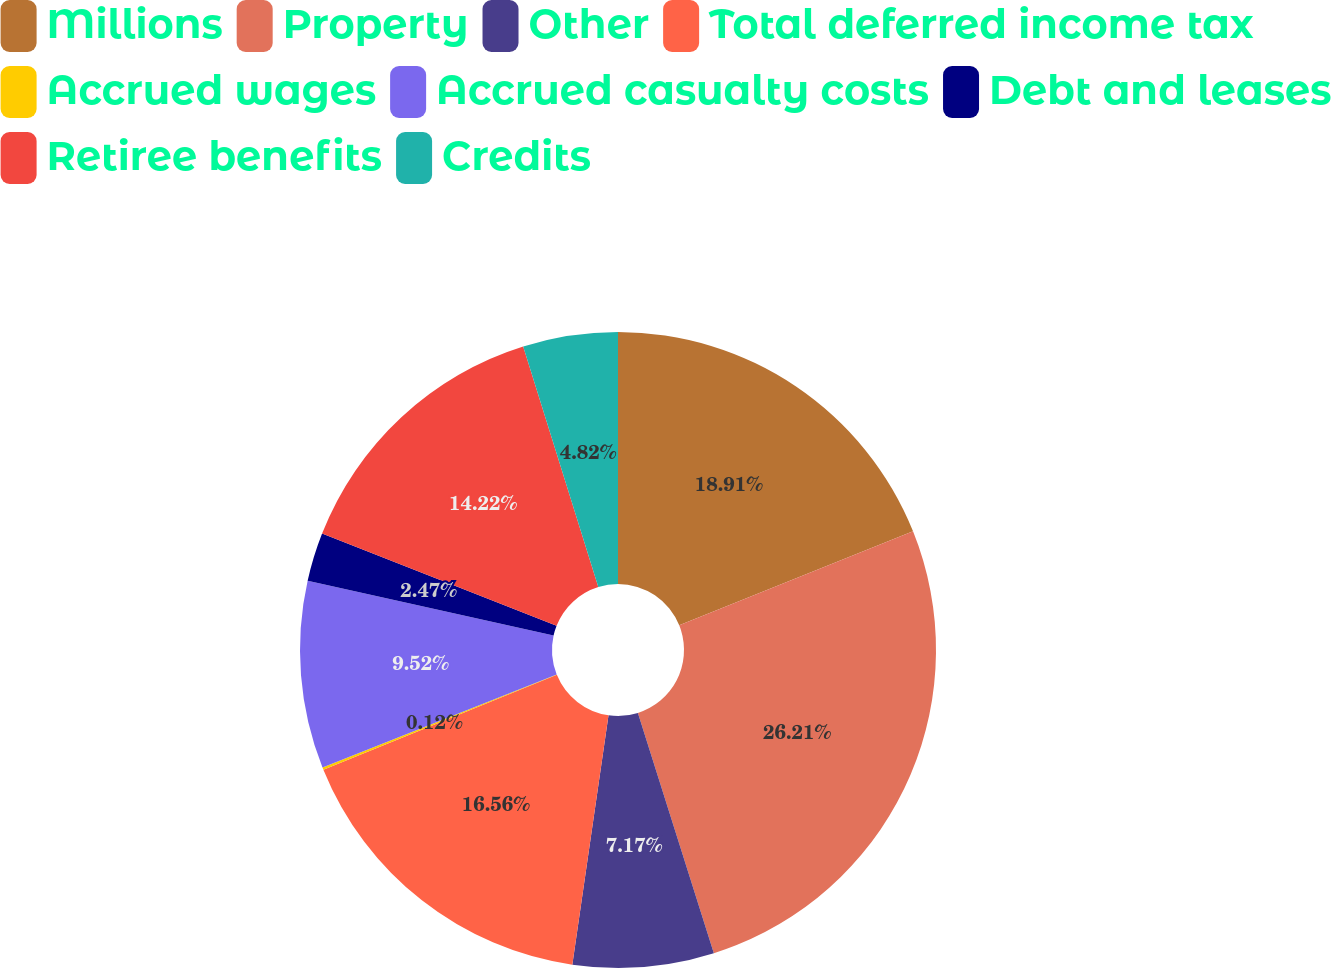Convert chart to OTSL. <chart><loc_0><loc_0><loc_500><loc_500><pie_chart><fcel>Millions<fcel>Property<fcel>Other<fcel>Total deferred income tax<fcel>Accrued wages<fcel>Accrued casualty costs<fcel>Debt and leases<fcel>Retiree benefits<fcel>Credits<nl><fcel>18.92%<fcel>26.22%<fcel>7.17%<fcel>16.57%<fcel>0.12%<fcel>9.52%<fcel>2.47%<fcel>14.22%<fcel>4.82%<nl></chart> 